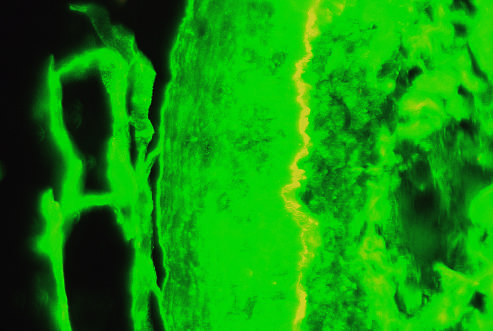s epidermis on the left side of the fluorescent band?
Answer the question using a single word or phrase. Yes 